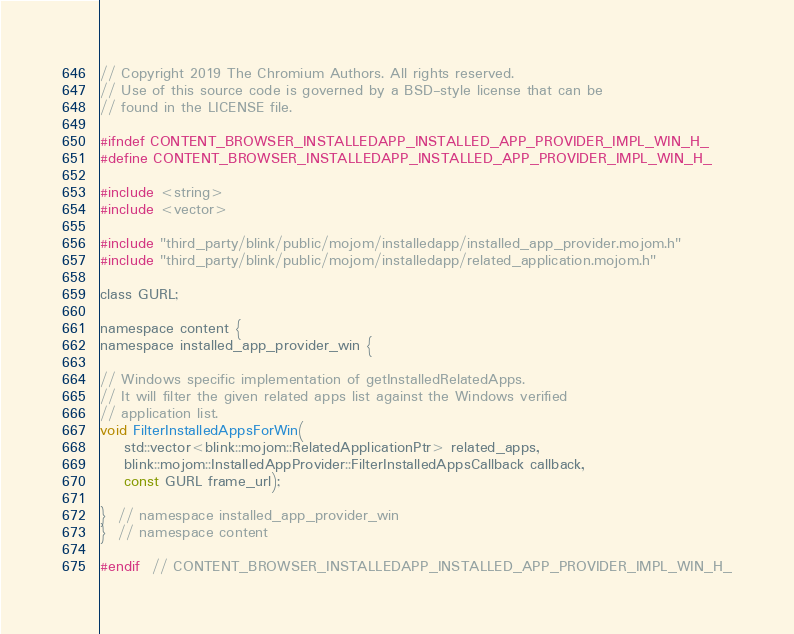<code> <loc_0><loc_0><loc_500><loc_500><_C_>// Copyright 2019 The Chromium Authors. All rights reserved.
// Use of this source code is governed by a BSD-style license that can be
// found in the LICENSE file.

#ifndef CONTENT_BROWSER_INSTALLEDAPP_INSTALLED_APP_PROVIDER_IMPL_WIN_H_
#define CONTENT_BROWSER_INSTALLEDAPP_INSTALLED_APP_PROVIDER_IMPL_WIN_H_

#include <string>
#include <vector>

#include "third_party/blink/public/mojom/installedapp/installed_app_provider.mojom.h"
#include "third_party/blink/public/mojom/installedapp/related_application.mojom.h"

class GURL;

namespace content {
namespace installed_app_provider_win {

// Windows specific implementation of getInstalledRelatedApps.
// It will filter the given related apps list against the Windows verified
// application list.
void FilterInstalledAppsForWin(
    std::vector<blink::mojom::RelatedApplicationPtr> related_apps,
    blink::mojom::InstalledAppProvider::FilterInstalledAppsCallback callback,
    const GURL frame_url);

}  // namespace installed_app_provider_win
}  // namespace content

#endif  // CONTENT_BROWSER_INSTALLEDAPP_INSTALLED_APP_PROVIDER_IMPL_WIN_H_
</code> 